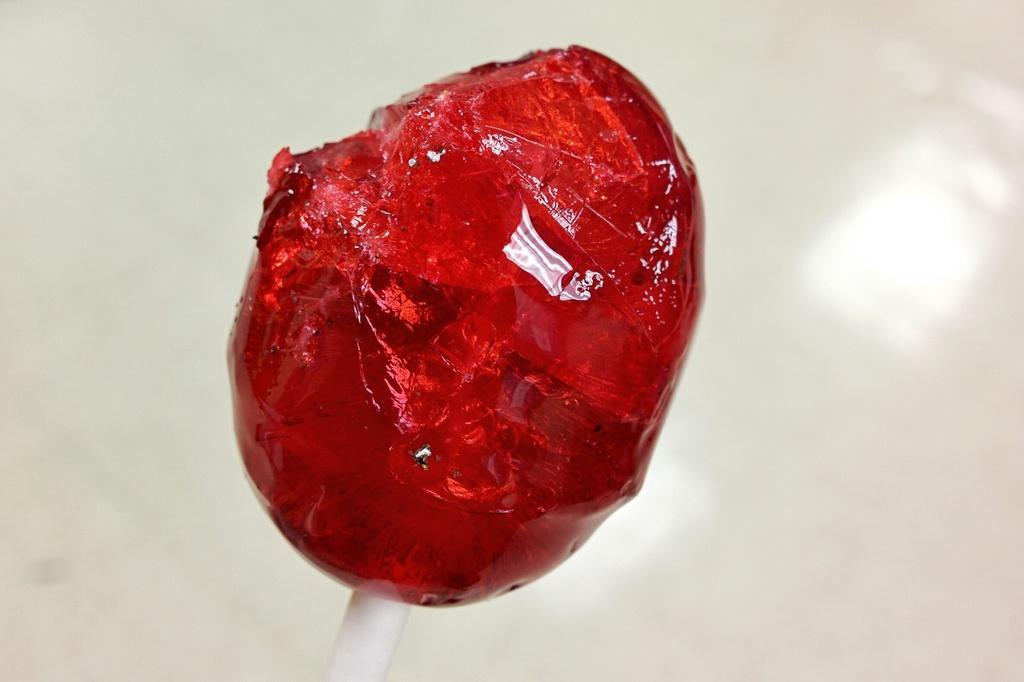Please provide a concise description of this image. In this image it looks like a lollipop. And there is a white colored background. 